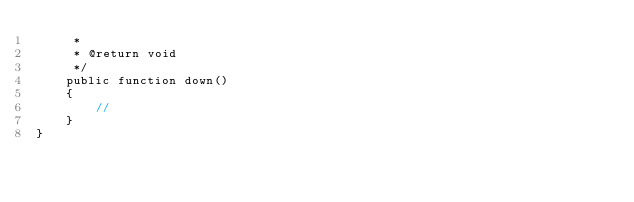<code> <loc_0><loc_0><loc_500><loc_500><_PHP_>     *
     * @return void
     */
    public function down()
    {
        //
    }
}
</code> 